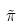<formula> <loc_0><loc_0><loc_500><loc_500>\tilde { \pi }</formula> 